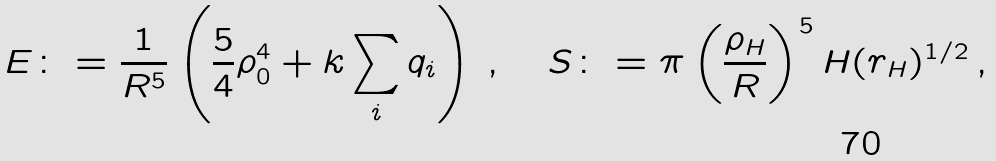<formula> <loc_0><loc_0><loc_500><loc_500>E \colon = \frac { 1 } { R ^ { 5 } } \left ( \frac { 5 } { 4 } \rho _ { 0 } ^ { 4 } + k \sum _ { i } q _ { i } \right ) \, , \quad S \colon = \pi \left ( \frac { \rho _ { H } } { R } \right ) ^ { 5 } H ( r _ { H } ) ^ { 1 / 2 } \, ,</formula> 